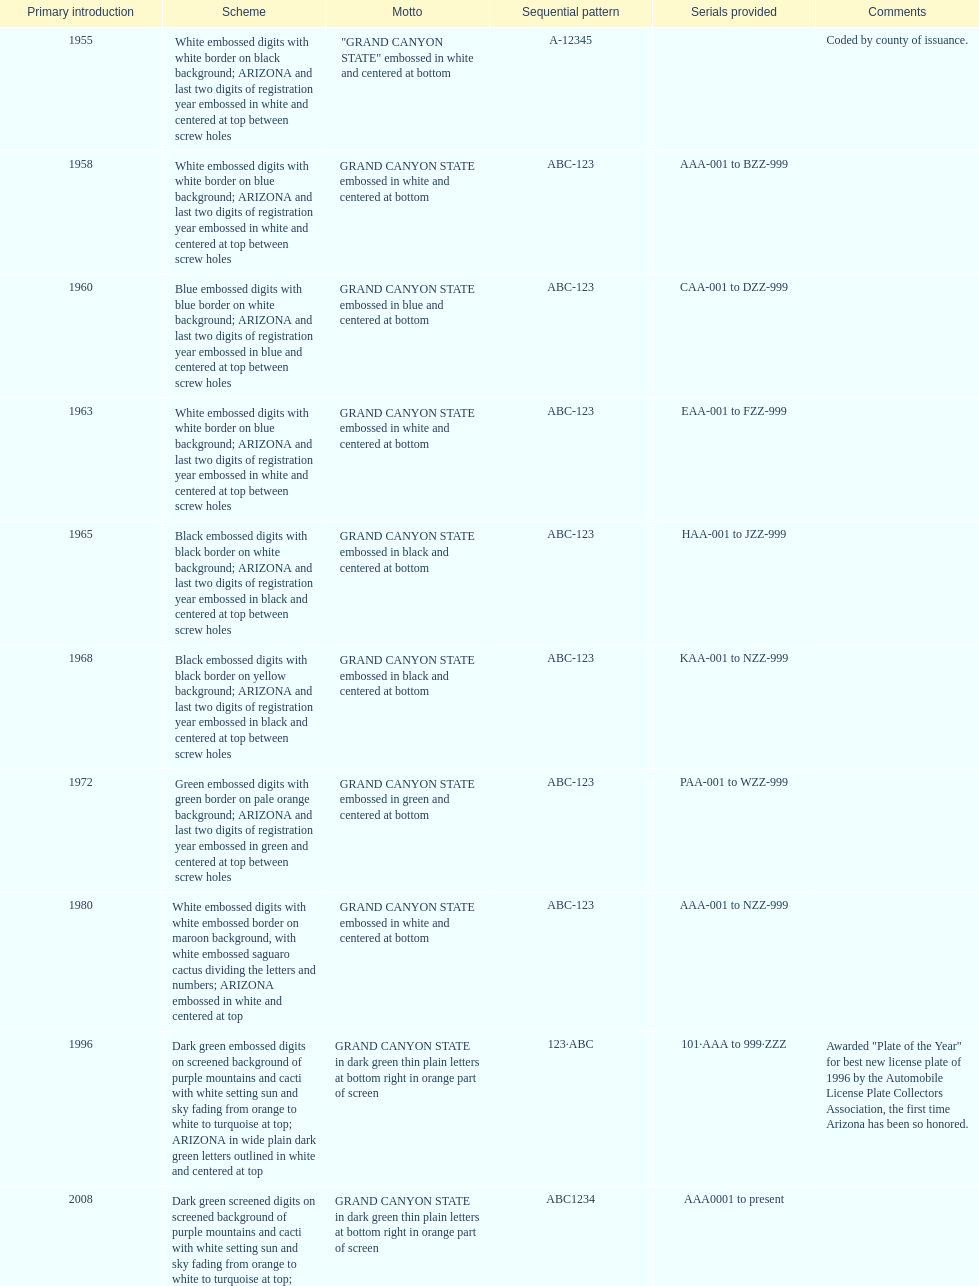What is the average serial format of the arizona license plates? ABC-123. 